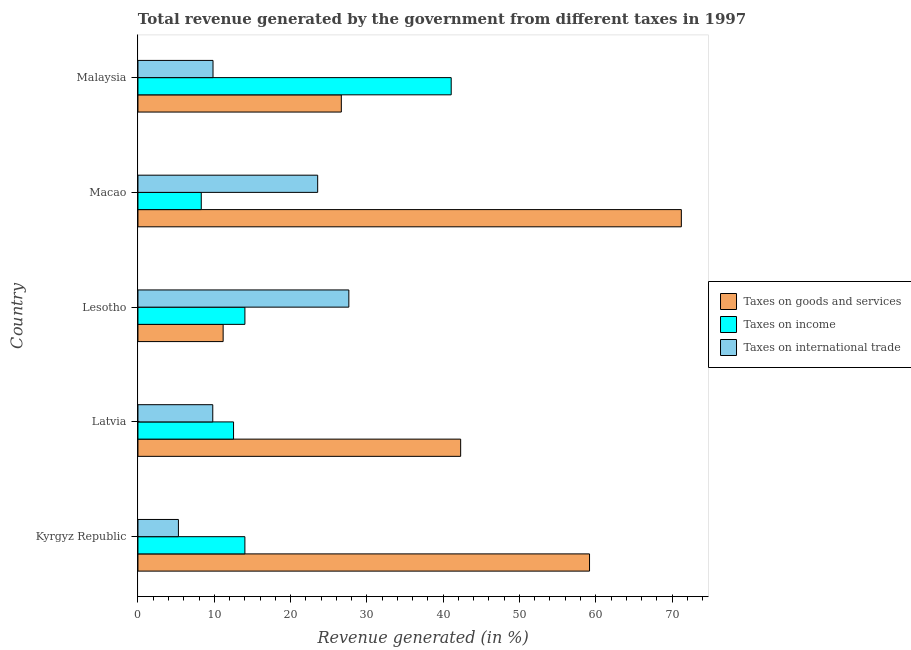How many bars are there on the 3rd tick from the top?
Ensure brevity in your answer.  3. What is the label of the 3rd group of bars from the top?
Keep it short and to the point. Lesotho. In how many cases, is the number of bars for a given country not equal to the number of legend labels?
Offer a terse response. 0. What is the percentage of revenue generated by tax on international trade in Malaysia?
Provide a short and direct response. 9.84. Across all countries, what is the maximum percentage of revenue generated by taxes on income?
Your answer should be compact. 41.06. Across all countries, what is the minimum percentage of revenue generated by taxes on income?
Offer a terse response. 8.3. In which country was the percentage of revenue generated by taxes on goods and services maximum?
Ensure brevity in your answer.  Macao. In which country was the percentage of revenue generated by taxes on income minimum?
Keep it short and to the point. Macao. What is the total percentage of revenue generated by tax on international trade in the graph?
Give a very brief answer. 76.14. What is the difference between the percentage of revenue generated by tax on international trade in Latvia and that in Malaysia?
Offer a terse response. -0.03. What is the difference between the percentage of revenue generated by tax on international trade in Kyrgyz Republic and the percentage of revenue generated by taxes on goods and services in Malaysia?
Your response must be concise. -21.35. What is the average percentage of revenue generated by taxes on income per country?
Keep it short and to the point. 17.98. What is the difference between the percentage of revenue generated by taxes on income and percentage of revenue generated by tax on international trade in Kyrgyz Republic?
Your answer should be very brief. 8.71. What is the ratio of the percentage of revenue generated by tax on international trade in Lesotho to that in Macao?
Your answer should be very brief. 1.17. Is the percentage of revenue generated by tax on international trade in Kyrgyz Republic less than that in Macao?
Your response must be concise. Yes. What is the difference between the highest and the second highest percentage of revenue generated by taxes on income?
Provide a succinct answer. 27.04. What is the difference between the highest and the lowest percentage of revenue generated by taxes on goods and services?
Keep it short and to the point. 60.05. What does the 3rd bar from the top in Macao represents?
Your answer should be very brief. Taxes on goods and services. What does the 1st bar from the bottom in Malaysia represents?
Provide a short and direct response. Taxes on goods and services. How many bars are there?
Give a very brief answer. 15. Are all the bars in the graph horizontal?
Keep it short and to the point. Yes. How many countries are there in the graph?
Your answer should be very brief. 5. Are the values on the major ticks of X-axis written in scientific E-notation?
Provide a succinct answer. No. Does the graph contain any zero values?
Make the answer very short. No. Does the graph contain grids?
Offer a terse response. No. Where does the legend appear in the graph?
Your response must be concise. Center right. How many legend labels are there?
Your answer should be compact. 3. What is the title of the graph?
Give a very brief answer. Total revenue generated by the government from different taxes in 1997. What is the label or title of the X-axis?
Offer a terse response. Revenue generated (in %). What is the label or title of the Y-axis?
Your response must be concise. Country. What is the Revenue generated (in %) of Taxes on goods and services in Kyrgyz Republic?
Your answer should be very brief. 59.18. What is the Revenue generated (in %) in Taxes on income in Kyrgyz Republic?
Your response must be concise. 14.01. What is the Revenue generated (in %) of Taxes on international trade in Kyrgyz Republic?
Keep it short and to the point. 5.3. What is the Revenue generated (in %) of Taxes on goods and services in Latvia?
Your answer should be compact. 42.29. What is the Revenue generated (in %) of Taxes on income in Latvia?
Make the answer very short. 12.53. What is the Revenue generated (in %) of Taxes on international trade in Latvia?
Provide a succinct answer. 9.8. What is the Revenue generated (in %) of Taxes on goods and services in Lesotho?
Keep it short and to the point. 11.16. What is the Revenue generated (in %) in Taxes on income in Lesotho?
Give a very brief answer. 14.02. What is the Revenue generated (in %) of Taxes on international trade in Lesotho?
Provide a short and direct response. 27.64. What is the Revenue generated (in %) of Taxes on goods and services in Macao?
Your answer should be very brief. 71.22. What is the Revenue generated (in %) of Taxes on income in Macao?
Your answer should be compact. 8.3. What is the Revenue generated (in %) of Taxes on international trade in Macao?
Offer a very short reply. 23.55. What is the Revenue generated (in %) of Taxes on goods and services in Malaysia?
Your answer should be very brief. 26.65. What is the Revenue generated (in %) in Taxes on income in Malaysia?
Keep it short and to the point. 41.06. What is the Revenue generated (in %) in Taxes on international trade in Malaysia?
Give a very brief answer. 9.84. Across all countries, what is the maximum Revenue generated (in %) in Taxes on goods and services?
Provide a short and direct response. 71.22. Across all countries, what is the maximum Revenue generated (in %) in Taxes on income?
Keep it short and to the point. 41.06. Across all countries, what is the maximum Revenue generated (in %) of Taxes on international trade?
Make the answer very short. 27.64. Across all countries, what is the minimum Revenue generated (in %) in Taxes on goods and services?
Make the answer very short. 11.16. Across all countries, what is the minimum Revenue generated (in %) in Taxes on income?
Give a very brief answer. 8.3. Across all countries, what is the minimum Revenue generated (in %) in Taxes on international trade?
Your response must be concise. 5.3. What is the total Revenue generated (in %) in Taxes on goods and services in the graph?
Your answer should be compact. 210.51. What is the total Revenue generated (in %) of Taxes on income in the graph?
Provide a succinct answer. 89.91. What is the total Revenue generated (in %) of Taxes on international trade in the graph?
Offer a terse response. 76.14. What is the difference between the Revenue generated (in %) of Taxes on goods and services in Kyrgyz Republic and that in Latvia?
Provide a short and direct response. 16.89. What is the difference between the Revenue generated (in %) in Taxes on income in Kyrgyz Republic and that in Latvia?
Give a very brief answer. 1.49. What is the difference between the Revenue generated (in %) in Taxes on international trade in Kyrgyz Republic and that in Latvia?
Ensure brevity in your answer.  -4.5. What is the difference between the Revenue generated (in %) of Taxes on goods and services in Kyrgyz Republic and that in Lesotho?
Ensure brevity in your answer.  48.02. What is the difference between the Revenue generated (in %) of Taxes on income in Kyrgyz Republic and that in Lesotho?
Offer a very short reply. -0. What is the difference between the Revenue generated (in %) of Taxes on international trade in Kyrgyz Republic and that in Lesotho?
Your response must be concise. -22.34. What is the difference between the Revenue generated (in %) in Taxes on goods and services in Kyrgyz Republic and that in Macao?
Provide a short and direct response. -12.03. What is the difference between the Revenue generated (in %) in Taxes on income in Kyrgyz Republic and that in Macao?
Offer a terse response. 5.72. What is the difference between the Revenue generated (in %) of Taxes on international trade in Kyrgyz Republic and that in Macao?
Make the answer very short. -18.25. What is the difference between the Revenue generated (in %) in Taxes on goods and services in Kyrgyz Republic and that in Malaysia?
Offer a very short reply. 32.53. What is the difference between the Revenue generated (in %) in Taxes on income in Kyrgyz Republic and that in Malaysia?
Offer a very short reply. -27.04. What is the difference between the Revenue generated (in %) of Taxes on international trade in Kyrgyz Republic and that in Malaysia?
Ensure brevity in your answer.  -4.53. What is the difference between the Revenue generated (in %) of Taxes on goods and services in Latvia and that in Lesotho?
Keep it short and to the point. 31.13. What is the difference between the Revenue generated (in %) of Taxes on income in Latvia and that in Lesotho?
Your answer should be very brief. -1.49. What is the difference between the Revenue generated (in %) in Taxes on international trade in Latvia and that in Lesotho?
Provide a short and direct response. -17.83. What is the difference between the Revenue generated (in %) of Taxes on goods and services in Latvia and that in Macao?
Your response must be concise. -28.92. What is the difference between the Revenue generated (in %) in Taxes on income in Latvia and that in Macao?
Offer a terse response. 4.23. What is the difference between the Revenue generated (in %) of Taxes on international trade in Latvia and that in Macao?
Keep it short and to the point. -13.75. What is the difference between the Revenue generated (in %) in Taxes on goods and services in Latvia and that in Malaysia?
Give a very brief answer. 15.64. What is the difference between the Revenue generated (in %) in Taxes on income in Latvia and that in Malaysia?
Offer a terse response. -28.53. What is the difference between the Revenue generated (in %) of Taxes on international trade in Latvia and that in Malaysia?
Offer a very short reply. -0.03. What is the difference between the Revenue generated (in %) in Taxes on goods and services in Lesotho and that in Macao?
Give a very brief answer. -60.05. What is the difference between the Revenue generated (in %) of Taxes on income in Lesotho and that in Macao?
Provide a succinct answer. 5.72. What is the difference between the Revenue generated (in %) of Taxes on international trade in Lesotho and that in Macao?
Your answer should be very brief. 4.08. What is the difference between the Revenue generated (in %) of Taxes on goods and services in Lesotho and that in Malaysia?
Make the answer very short. -15.49. What is the difference between the Revenue generated (in %) in Taxes on income in Lesotho and that in Malaysia?
Your answer should be very brief. -27.04. What is the difference between the Revenue generated (in %) in Taxes on international trade in Lesotho and that in Malaysia?
Provide a short and direct response. 17.8. What is the difference between the Revenue generated (in %) of Taxes on goods and services in Macao and that in Malaysia?
Make the answer very short. 44.56. What is the difference between the Revenue generated (in %) in Taxes on income in Macao and that in Malaysia?
Offer a terse response. -32.76. What is the difference between the Revenue generated (in %) in Taxes on international trade in Macao and that in Malaysia?
Provide a short and direct response. 13.72. What is the difference between the Revenue generated (in %) in Taxes on goods and services in Kyrgyz Republic and the Revenue generated (in %) in Taxes on income in Latvia?
Ensure brevity in your answer.  46.66. What is the difference between the Revenue generated (in %) of Taxes on goods and services in Kyrgyz Republic and the Revenue generated (in %) of Taxes on international trade in Latvia?
Provide a short and direct response. 49.38. What is the difference between the Revenue generated (in %) in Taxes on income in Kyrgyz Republic and the Revenue generated (in %) in Taxes on international trade in Latvia?
Ensure brevity in your answer.  4.21. What is the difference between the Revenue generated (in %) of Taxes on goods and services in Kyrgyz Republic and the Revenue generated (in %) of Taxes on income in Lesotho?
Give a very brief answer. 45.17. What is the difference between the Revenue generated (in %) in Taxes on goods and services in Kyrgyz Republic and the Revenue generated (in %) in Taxes on international trade in Lesotho?
Provide a succinct answer. 31.54. What is the difference between the Revenue generated (in %) of Taxes on income in Kyrgyz Republic and the Revenue generated (in %) of Taxes on international trade in Lesotho?
Give a very brief answer. -13.62. What is the difference between the Revenue generated (in %) of Taxes on goods and services in Kyrgyz Republic and the Revenue generated (in %) of Taxes on income in Macao?
Offer a terse response. 50.89. What is the difference between the Revenue generated (in %) in Taxes on goods and services in Kyrgyz Republic and the Revenue generated (in %) in Taxes on international trade in Macao?
Your response must be concise. 35.63. What is the difference between the Revenue generated (in %) of Taxes on income in Kyrgyz Republic and the Revenue generated (in %) of Taxes on international trade in Macao?
Your response must be concise. -9.54. What is the difference between the Revenue generated (in %) in Taxes on goods and services in Kyrgyz Republic and the Revenue generated (in %) in Taxes on income in Malaysia?
Keep it short and to the point. 18.13. What is the difference between the Revenue generated (in %) of Taxes on goods and services in Kyrgyz Republic and the Revenue generated (in %) of Taxes on international trade in Malaysia?
Make the answer very short. 49.35. What is the difference between the Revenue generated (in %) in Taxes on income in Kyrgyz Republic and the Revenue generated (in %) in Taxes on international trade in Malaysia?
Offer a terse response. 4.18. What is the difference between the Revenue generated (in %) of Taxes on goods and services in Latvia and the Revenue generated (in %) of Taxes on income in Lesotho?
Offer a terse response. 28.28. What is the difference between the Revenue generated (in %) of Taxes on goods and services in Latvia and the Revenue generated (in %) of Taxes on international trade in Lesotho?
Offer a terse response. 14.65. What is the difference between the Revenue generated (in %) in Taxes on income in Latvia and the Revenue generated (in %) in Taxes on international trade in Lesotho?
Your answer should be very brief. -15.11. What is the difference between the Revenue generated (in %) of Taxes on goods and services in Latvia and the Revenue generated (in %) of Taxes on income in Macao?
Your answer should be compact. 34. What is the difference between the Revenue generated (in %) in Taxes on goods and services in Latvia and the Revenue generated (in %) in Taxes on international trade in Macao?
Your answer should be compact. 18.74. What is the difference between the Revenue generated (in %) in Taxes on income in Latvia and the Revenue generated (in %) in Taxes on international trade in Macao?
Your response must be concise. -11.03. What is the difference between the Revenue generated (in %) of Taxes on goods and services in Latvia and the Revenue generated (in %) of Taxes on income in Malaysia?
Offer a terse response. 1.24. What is the difference between the Revenue generated (in %) of Taxes on goods and services in Latvia and the Revenue generated (in %) of Taxes on international trade in Malaysia?
Offer a terse response. 32.46. What is the difference between the Revenue generated (in %) of Taxes on income in Latvia and the Revenue generated (in %) of Taxes on international trade in Malaysia?
Your answer should be compact. 2.69. What is the difference between the Revenue generated (in %) in Taxes on goods and services in Lesotho and the Revenue generated (in %) in Taxes on income in Macao?
Your response must be concise. 2.87. What is the difference between the Revenue generated (in %) of Taxes on goods and services in Lesotho and the Revenue generated (in %) of Taxes on international trade in Macao?
Make the answer very short. -12.39. What is the difference between the Revenue generated (in %) of Taxes on income in Lesotho and the Revenue generated (in %) of Taxes on international trade in Macao?
Keep it short and to the point. -9.54. What is the difference between the Revenue generated (in %) in Taxes on goods and services in Lesotho and the Revenue generated (in %) in Taxes on income in Malaysia?
Your answer should be very brief. -29.89. What is the difference between the Revenue generated (in %) in Taxes on goods and services in Lesotho and the Revenue generated (in %) in Taxes on international trade in Malaysia?
Provide a short and direct response. 1.33. What is the difference between the Revenue generated (in %) of Taxes on income in Lesotho and the Revenue generated (in %) of Taxes on international trade in Malaysia?
Your response must be concise. 4.18. What is the difference between the Revenue generated (in %) of Taxes on goods and services in Macao and the Revenue generated (in %) of Taxes on income in Malaysia?
Give a very brief answer. 30.16. What is the difference between the Revenue generated (in %) of Taxes on goods and services in Macao and the Revenue generated (in %) of Taxes on international trade in Malaysia?
Offer a terse response. 61.38. What is the difference between the Revenue generated (in %) in Taxes on income in Macao and the Revenue generated (in %) in Taxes on international trade in Malaysia?
Give a very brief answer. -1.54. What is the average Revenue generated (in %) of Taxes on goods and services per country?
Your answer should be compact. 42.1. What is the average Revenue generated (in %) of Taxes on income per country?
Give a very brief answer. 17.98. What is the average Revenue generated (in %) in Taxes on international trade per country?
Offer a very short reply. 15.23. What is the difference between the Revenue generated (in %) in Taxes on goods and services and Revenue generated (in %) in Taxes on income in Kyrgyz Republic?
Keep it short and to the point. 45.17. What is the difference between the Revenue generated (in %) in Taxes on goods and services and Revenue generated (in %) in Taxes on international trade in Kyrgyz Republic?
Ensure brevity in your answer.  53.88. What is the difference between the Revenue generated (in %) of Taxes on income and Revenue generated (in %) of Taxes on international trade in Kyrgyz Republic?
Your answer should be very brief. 8.71. What is the difference between the Revenue generated (in %) of Taxes on goods and services and Revenue generated (in %) of Taxes on income in Latvia?
Ensure brevity in your answer.  29.77. What is the difference between the Revenue generated (in %) in Taxes on goods and services and Revenue generated (in %) in Taxes on international trade in Latvia?
Offer a very short reply. 32.49. What is the difference between the Revenue generated (in %) of Taxes on income and Revenue generated (in %) of Taxes on international trade in Latvia?
Make the answer very short. 2.72. What is the difference between the Revenue generated (in %) of Taxes on goods and services and Revenue generated (in %) of Taxes on income in Lesotho?
Your answer should be very brief. -2.85. What is the difference between the Revenue generated (in %) in Taxes on goods and services and Revenue generated (in %) in Taxes on international trade in Lesotho?
Keep it short and to the point. -16.47. What is the difference between the Revenue generated (in %) in Taxes on income and Revenue generated (in %) in Taxes on international trade in Lesotho?
Give a very brief answer. -13.62. What is the difference between the Revenue generated (in %) in Taxes on goods and services and Revenue generated (in %) in Taxes on income in Macao?
Your answer should be compact. 62.92. What is the difference between the Revenue generated (in %) of Taxes on goods and services and Revenue generated (in %) of Taxes on international trade in Macao?
Offer a very short reply. 47.66. What is the difference between the Revenue generated (in %) in Taxes on income and Revenue generated (in %) in Taxes on international trade in Macao?
Provide a succinct answer. -15.26. What is the difference between the Revenue generated (in %) of Taxes on goods and services and Revenue generated (in %) of Taxes on income in Malaysia?
Your response must be concise. -14.4. What is the difference between the Revenue generated (in %) of Taxes on goods and services and Revenue generated (in %) of Taxes on international trade in Malaysia?
Ensure brevity in your answer.  16.82. What is the difference between the Revenue generated (in %) of Taxes on income and Revenue generated (in %) of Taxes on international trade in Malaysia?
Make the answer very short. 31.22. What is the ratio of the Revenue generated (in %) in Taxes on goods and services in Kyrgyz Republic to that in Latvia?
Provide a short and direct response. 1.4. What is the ratio of the Revenue generated (in %) of Taxes on income in Kyrgyz Republic to that in Latvia?
Offer a terse response. 1.12. What is the ratio of the Revenue generated (in %) in Taxes on international trade in Kyrgyz Republic to that in Latvia?
Give a very brief answer. 0.54. What is the ratio of the Revenue generated (in %) in Taxes on goods and services in Kyrgyz Republic to that in Lesotho?
Offer a very short reply. 5.3. What is the ratio of the Revenue generated (in %) in Taxes on income in Kyrgyz Republic to that in Lesotho?
Your response must be concise. 1. What is the ratio of the Revenue generated (in %) in Taxes on international trade in Kyrgyz Republic to that in Lesotho?
Provide a short and direct response. 0.19. What is the ratio of the Revenue generated (in %) in Taxes on goods and services in Kyrgyz Republic to that in Macao?
Ensure brevity in your answer.  0.83. What is the ratio of the Revenue generated (in %) of Taxes on income in Kyrgyz Republic to that in Macao?
Keep it short and to the point. 1.69. What is the ratio of the Revenue generated (in %) in Taxes on international trade in Kyrgyz Republic to that in Macao?
Your response must be concise. 0.23. What is the ratio of the Revenue generated (in %) in Taxes on goods and services in Kyrgyz Republic to that in Malaysia?
Keep it short and to the point. 2.22. What is the ratio of the Revenue generated (in %) in Taxes on income in Kyrgyz Republic to that in Malaysia?
Keep it short and to the point. 0.34. What is the ratio of the Revenue generated (in %) in Taxes on international trade in Kyrgyz Republic to that in Malaysia?
Ensure brevity in your answer.  0.54. What is the ratio of the Revenue generated (in %) of Taxes on goods and services in Latvia to that in Lesotho?
Provide a short and direct response. 3.79. What is the ratio of the Revenue generated (in %) in Taxes on income in Latvia to that in Lesotho?
Your answer should be very brief. 0.89. What is the ratio of the Revenue generated (in %) of Taxes on international trade in Latvia to that in Lesotho?
Keep it short and to the point. 0.35. What is the ratio of the Revenue generated (in %) in Taxes on goods and services in Latvia to that in Macao?
Your response must be concise. 0.59. What is the ratio of the Revenue generated (in %) of Taxes on income in Latvia to that in Macao?
Your answer should be compact. 1.51. What is the ratio of the Revenue generated (in %) of Taxes on international trade in Latvia to that in Macao?
Provide a short and direct response. 0.42. What is the ratio of the Revenue generated (in %) in Taxes on goods and services in Latvia to that in Malaysia?
Your answer should be compact. 1.59. What is the ratio of the Revenue generated (in %) in Taxes on income in Latvia to that in Malaysia?
Offer a terse response. 0.31. What is the ratio of the Revenue generated (in %) in Taxes on goods and services in Lesotho to that in Macao?
Provide a short and direct response. 0.16. What is the ratio of the Revenue generated (in %) in Taxes on income in Lesotho to that in Macao?
Ensure brevity in your answer.  1.69. What is the ratio of the Revenue generated (in %) of Taxes on international trade in Lesotho to that in Macao?
Your answer should be very brief. 1.17. What is the ratio of the Revenue generated (in %) of Taxes on goods and services in Lesotho to that in Malaysia?
Your response must be concise. 0.42. What is the ratio of the Revenue generated (in %) of Taxes on income in Lesotho to that in Malaysia?
Make the answer very short. 0.34. What is the ratio of the Revenue generated (in %) of Taxes on international trade in Lesotho to that in Malaysia?
Provide a short and direct response. 2.81. What is the ratio of the Revenue generated (in %) in Taxes on goods and services in Macao to that in Malaysia?
Your response must be concise. 2.67. What is the ratio of the Revenue generated (in %) in Taxes on income in Macao to that in Malaysia?
Your response must be concise. 0.2. What is the ratio of the Revenue generated (in %) in Taxes on international trade in Macao to that in Malaysia?
Give a very brief answer. 2.39. What is the difference between the highest and the second highest Revenue generated (in %) of Taxes on goods and services?
Provide a short and direct response. 12.03. What is the difference between the highest and the second highest Revenue generated (in %) in Taxes on income?
Ensure brevity in your answer.  27.04. What is the difference between the highest and the second highest Revenue generated (in %) of Taxes on international trade?
Offer a terse response. 4.08. What is the difference between the highest and the lowest Revenue generated (in %) in Taxes on goods and services?
Provide a succinct answer. 60.05. What is the difference between the highest and the lowest Revenue generated (in %) of Taxes on income?
Keep it short and to the point. 32.76. What is the difference between the highest and the lowest Revenue generated (in %) in Taxes on international trade?
Offer a terse response. 22.34. 